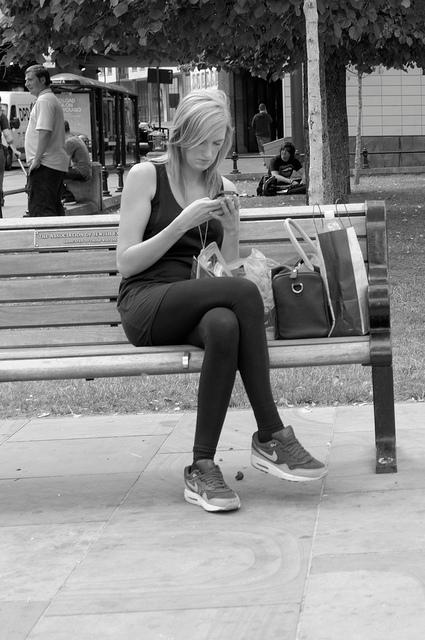What are the shoes that the girl is wearing a good use for? Please explain your reasoning. running. The girl has sneakers on. 